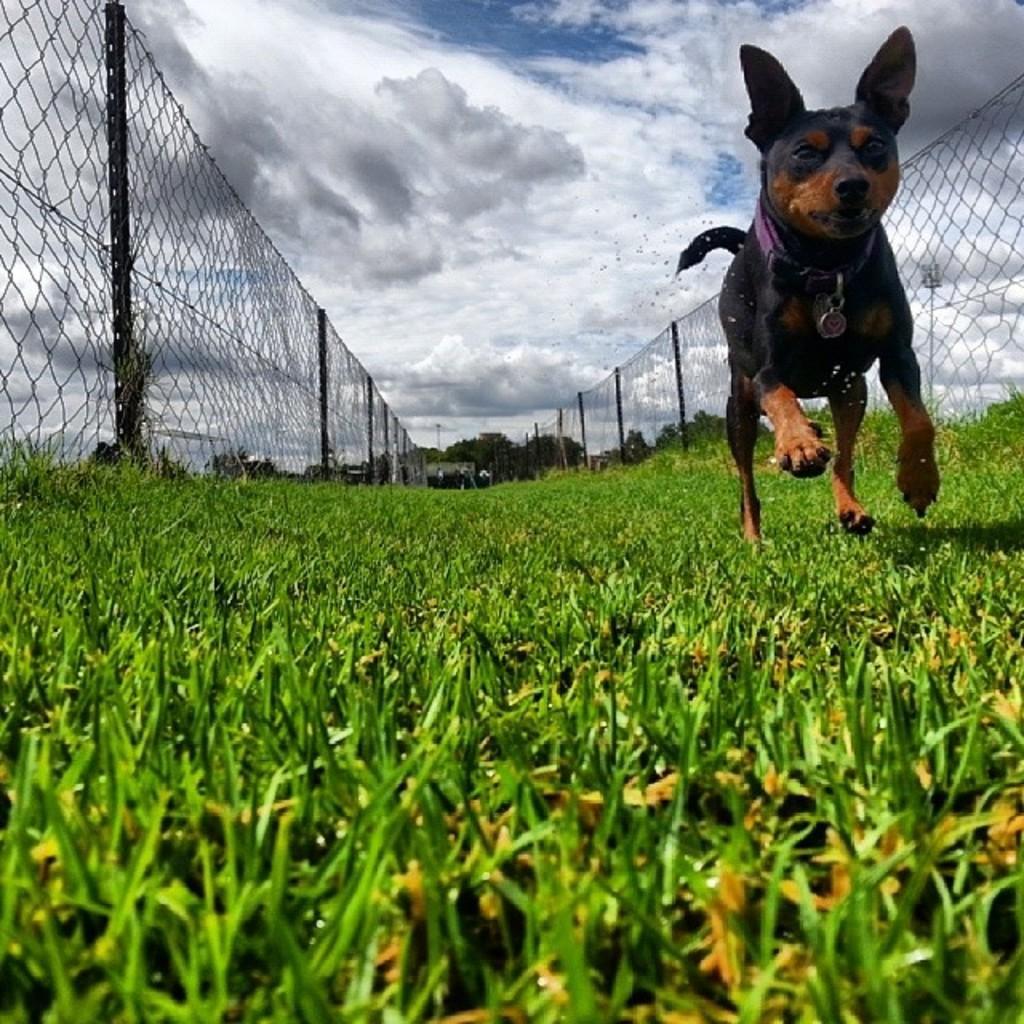How would you summarize this image in a sentence or two? In this image there are cloudś in the sky, there is fencing, there is grass, there is a dog running. 